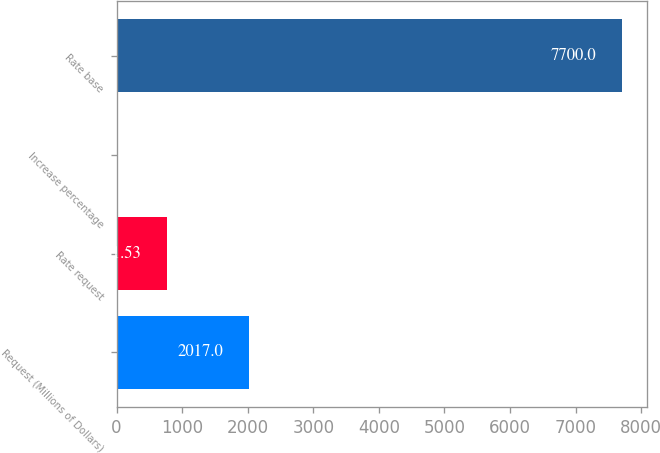<chart> <loc_0><loc_0><loc_500><loc_500><bar_chart><fcel>Request (Millions of Dollars)<fcel>Rate request<fcel>Increase percentage<fcel>Rate base<nl><fcel>2017<fcel>771.53<fcel>1.7<fcel>7700<nl></chart> 